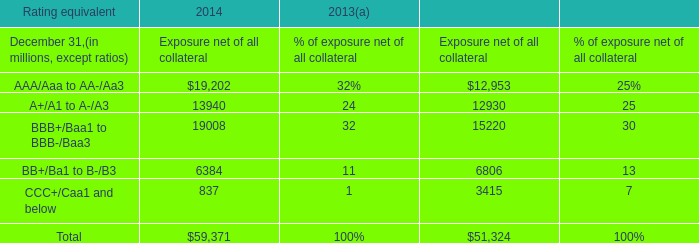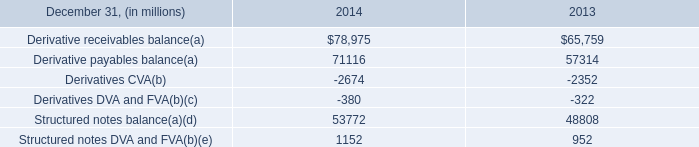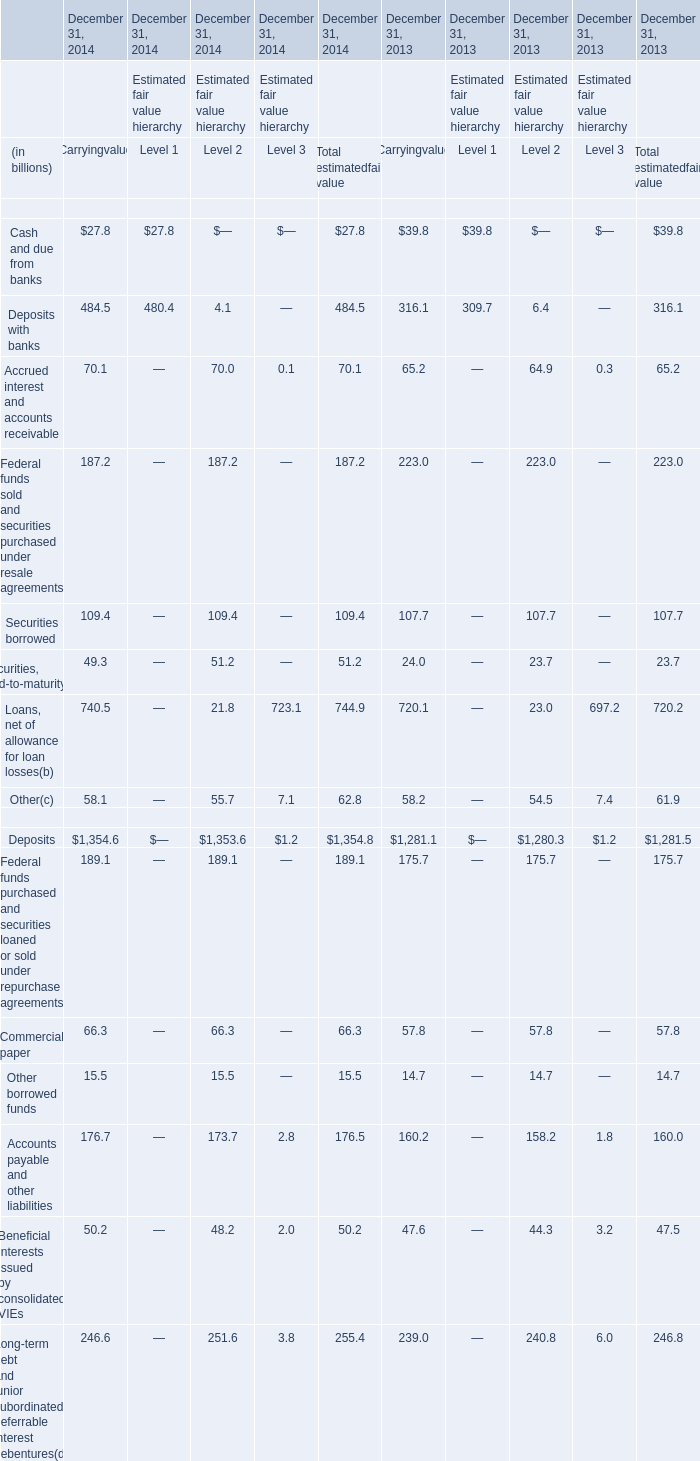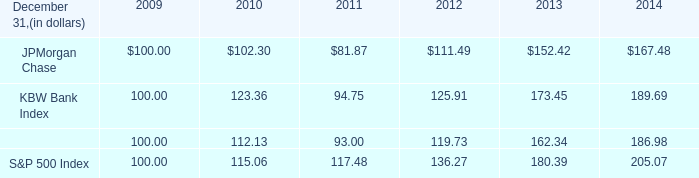by what total amount , from 2013 to 2014 , did total derivative receivable balances decrease or payable balances increase? 
Computations: ((2674 + 2352) + (380 + 322))
Answer: 5728.0. 